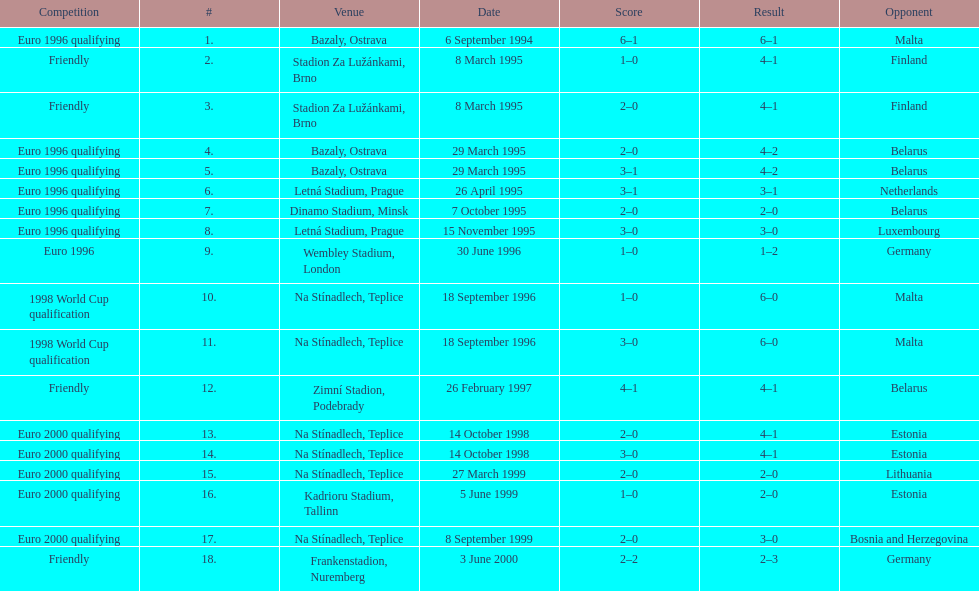Bazaly, ostrava was used on 6 september 1004, but what venue was used on 18 september 1996? Na Stínadlech, Teplice. 